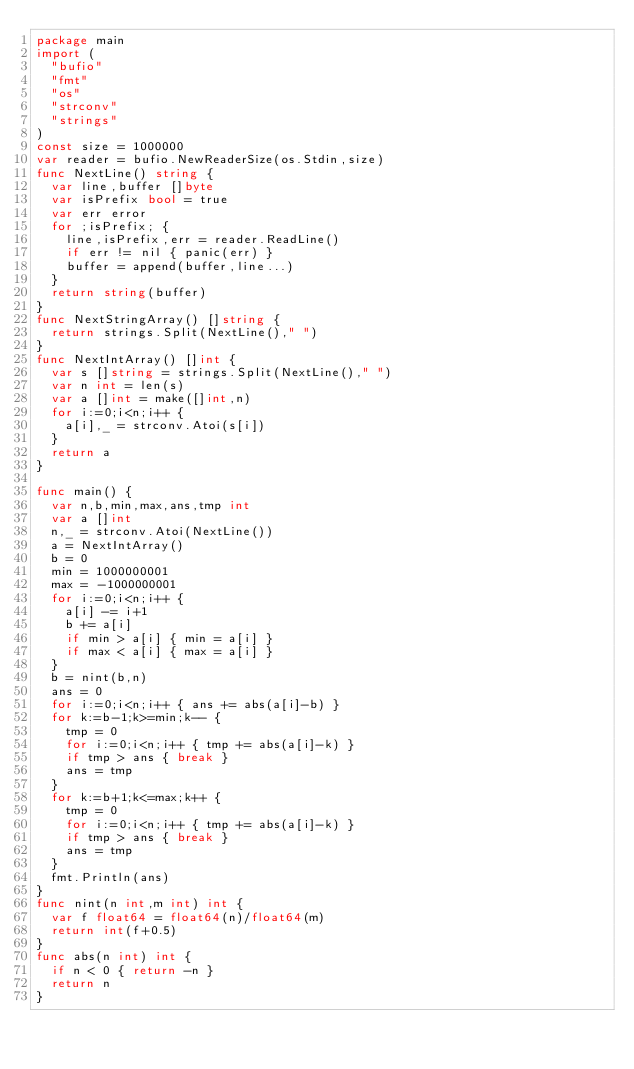<code> <loc_0><loc_0><loc_500><loc_500><_Go_>package main
import (
  "bufio"
  "fmt"
  "os"
  "strconv"
  "strings"
)
const size = 1000000
var reader = bufio.NewReaderSize(os.Stdin,size)
func NextLine() string {
  var line,buffer []byte
  var isPrefix bool = true
  var err error
  for ;isPrefix; {
    line,isPrefix,err = reader.ReadLine()
    if err != nil { panic(err) }
    buffer = append(buffer,line...)
  }
  return string(buffer)
}
func NextStringArray() []string {
  return strings.Split(NextLine()," ")
}
func NextIntArray() []int {
  var s []string = strings.Split(NextLine()," ")
  var n int = len(s)
  var a []int = make([]int,n)
  for i:=0;i<n;i++ {
    a[i],_ = strconv.Atoi(s[i])
  }
  return a
}

func main() {
  var n,b,min,max,ans,tmp int
  var a []int
  n,_ = strconv.Atoi(NextLine())
  a = NextIntArray()
  b = 0
  min = 1000000001
  max = -1000000001
  for i:=0;i<n;i++ {
    a[i] -= i+1
    b += a[i]
    if min > a[i] { min = a[i] }
    if max < a[i] { max = a[i] }
  }
  b = nint(b,n)
  ans = 0
  for i:=0;i<n;i++ { ans += abs(a[i]-b) }
  for k:=b-1;k>=min;k-- {
    tmp = 0
    for i:=0;i<n;i++ { tmp += abs(a[i]-k) }
    if tmp > ans { break }
    ans = tmp
  }
  for k:=b+1;k<=max;k++ {
    tmp = 0
    for i:=0;i<n;i++ { tmp += abs(a[i]-k) }
    if tmp > ans { break }
    ans = tmp
  }
  fmt.Println(ans)
}
func nint(n int,m int) int {
  var f float64 = float64(n)/float64(m)
  return int(f+0.5)
}
func abs(n int) int {
  if n < 0 { return -n }
  return n
}</code> 